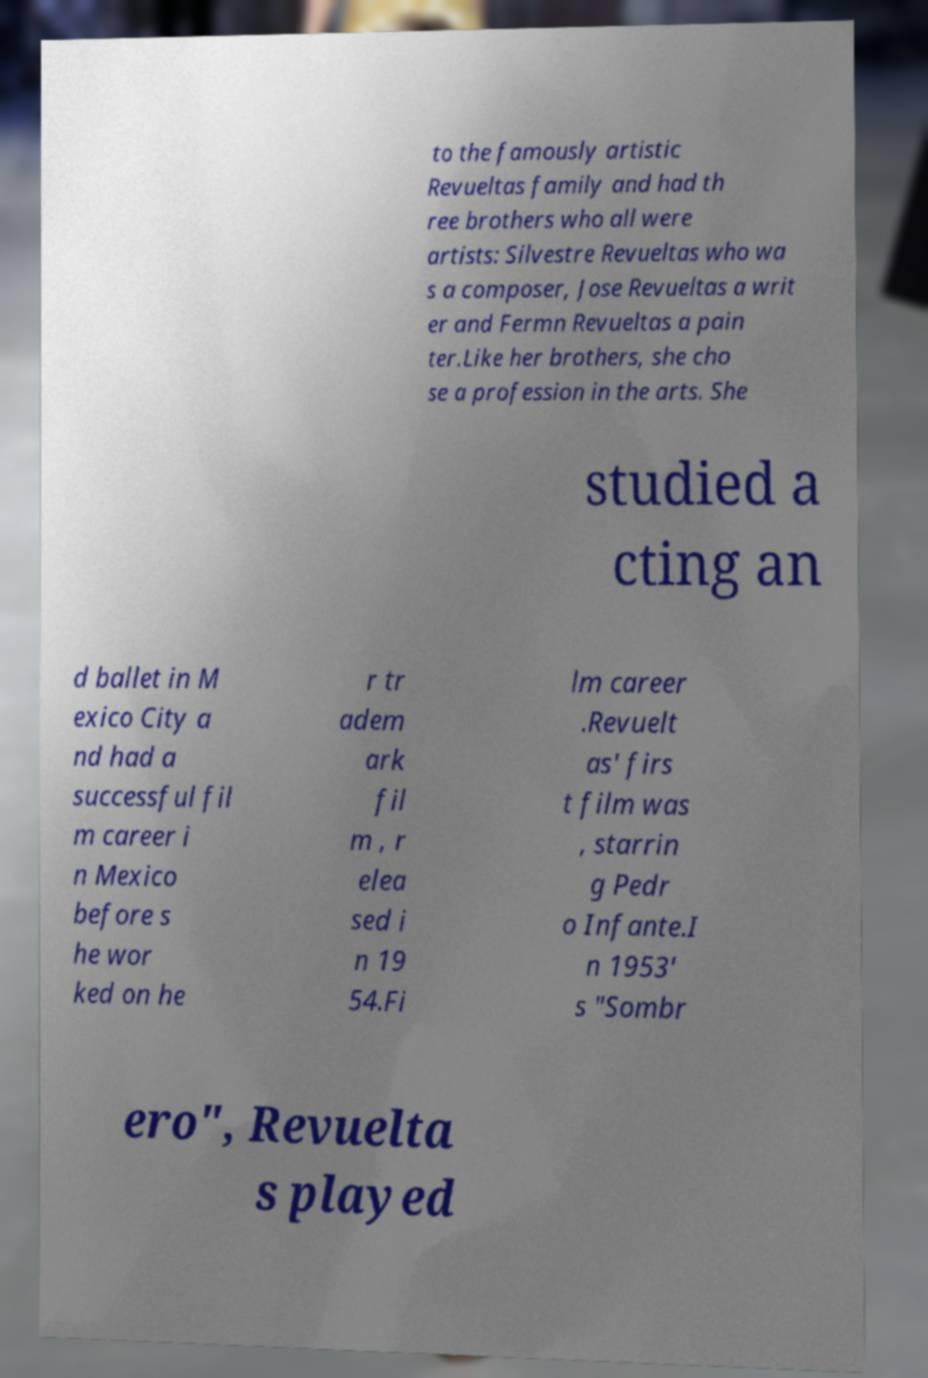Please read and relay the text visible in this image. What does it say? to the famously artistic Revueltas family and had th ree brothers who all were artists: Silvestre Revueltas who wa s a composer, Jose Revueltas a writ er and Fermn Revueltas a pain ter.Like her brothers, she cho se a profession in the arts. She studied a cting an d ballet in M exico City a nd had a successful fil m career i n Mexico before s he wor ked on he r tr adem ark fil m , r elea sed i n 19 54.Fi lm career .Revuelt as' firs t film was , starrin g Pedr o Infante.I n 1953' s "Sombr ero", Revuelta s played 